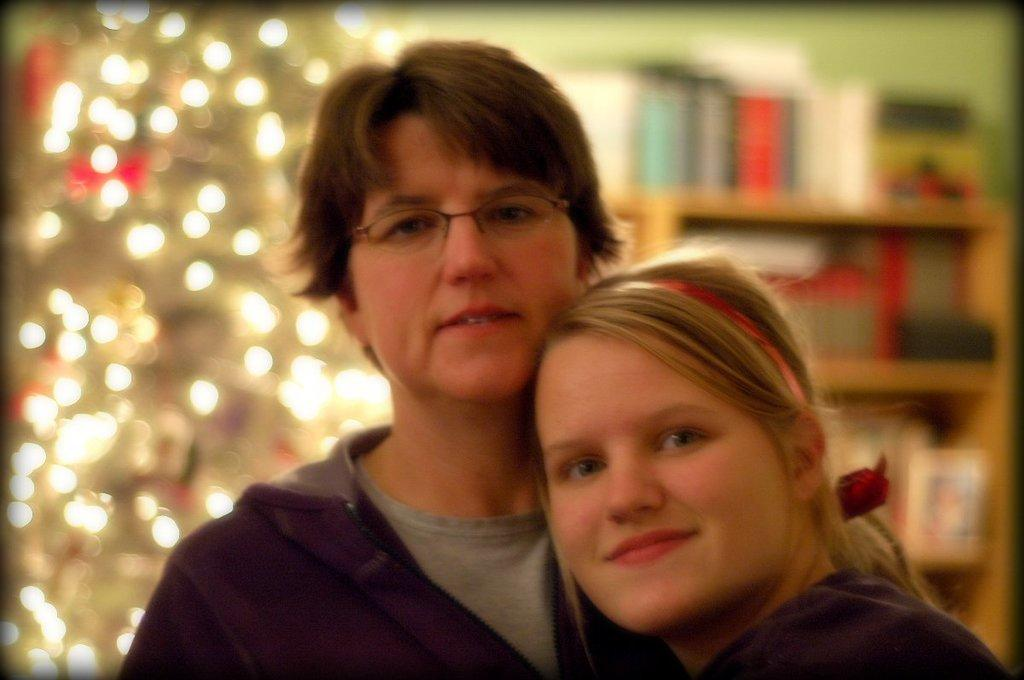How many people are present in the image? There is a man and a woman present in the image. What can be seen in the background of the image? There are decor lights and shelves in the background of the image. What type of crown is the man wearing in the image? There is no crown present in the image; the man is not wearing any headwear. 